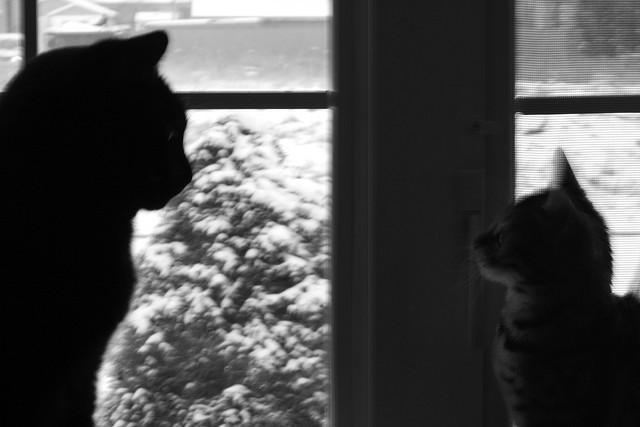How many baby kittens are there?
Give a very brief answer. 1. How many cats are in the picture?
Give a very brief answer. 2. How many people can be seen?
Give a very brief answer. 0. 